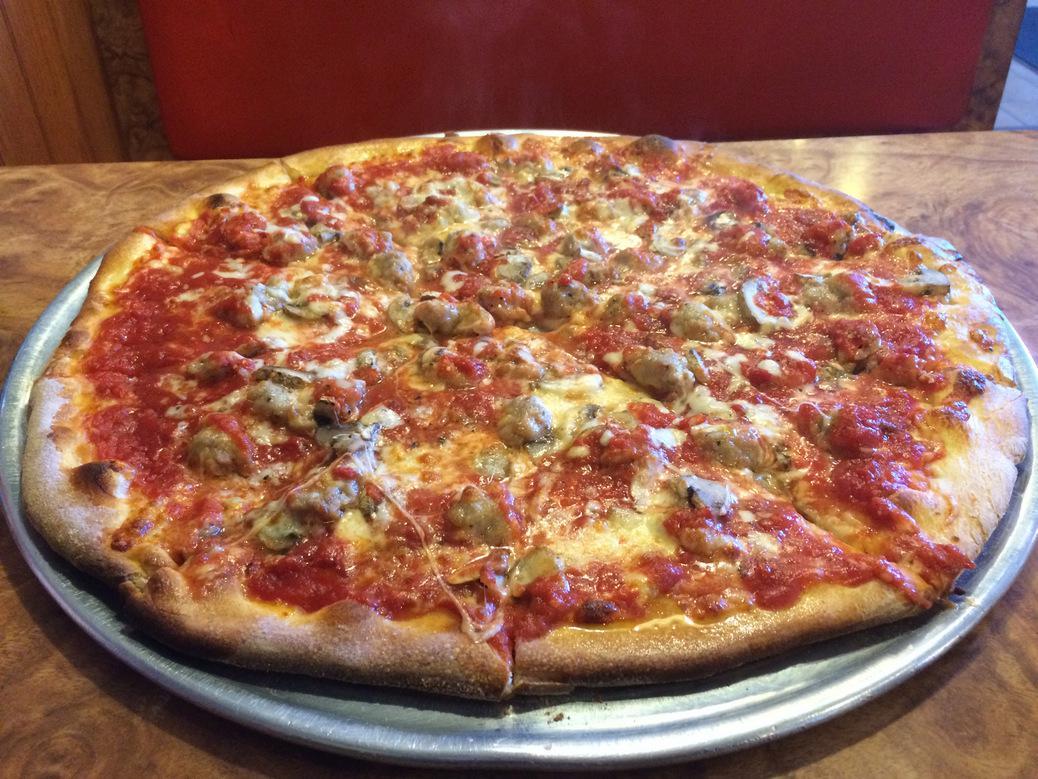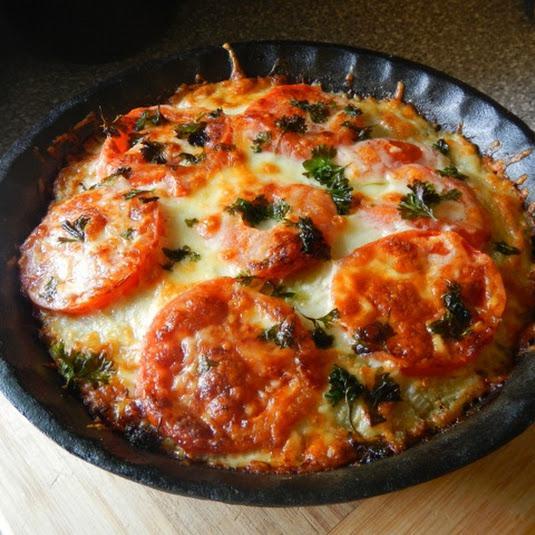The first image is the image on the left, the second image is the image on the right. Examine the images to the left and right. Is the description "Large slices of tomato sit on top of a pizza." accurate? Answer yes or no. Yes. The first image is the image on the left, the second image is the image on the right. Given the left and right images, does the statement "Each image shows a pizza with no slices removed, and one image features a pizza topped with round tomato slices and a green leafy garnish." hold true? Answer yes or no. Yes. 